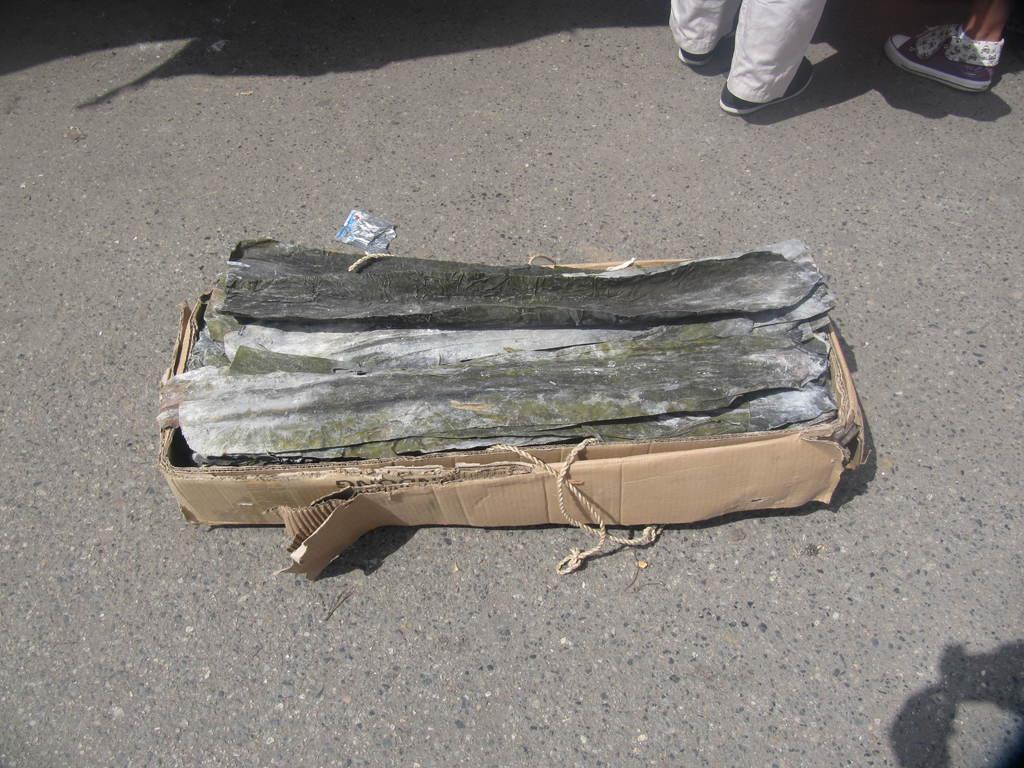What is inside the cardboard box in the image? There are objects and ropes in the cardboard box. Where is the cardboard box located in the image? The cardboard box is placed on the ground. Can you describe the people visible in the image? Unfortunately, the provided facts do not mention any details about the people in the image. What type of whip can be seen in the hands of the people in the image? There is no mention of a whip or any people holding a whip in the provided facts. 